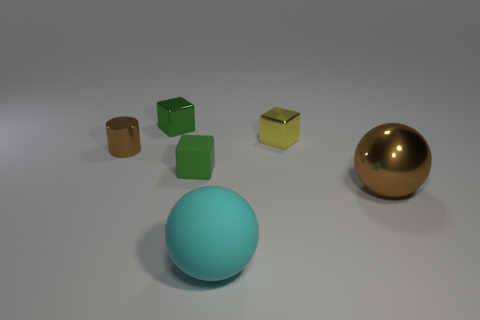Subtract all blue spheres. How many green cubes are left? 2 Add 4 small shiny cylinders. How many objects exist? 10 Subtract all cylinders. How many objects are left? 5 Add 4 yellow cubes. How many yellow cubes are left? 5 Add 3 green cubes. How many green cubes exist? 5 Subtract 0 red spheres. How many objects are left? 6 Subtract all tiny blue rubber objects. Subtract all large metal balls. How many objects are left? 5 